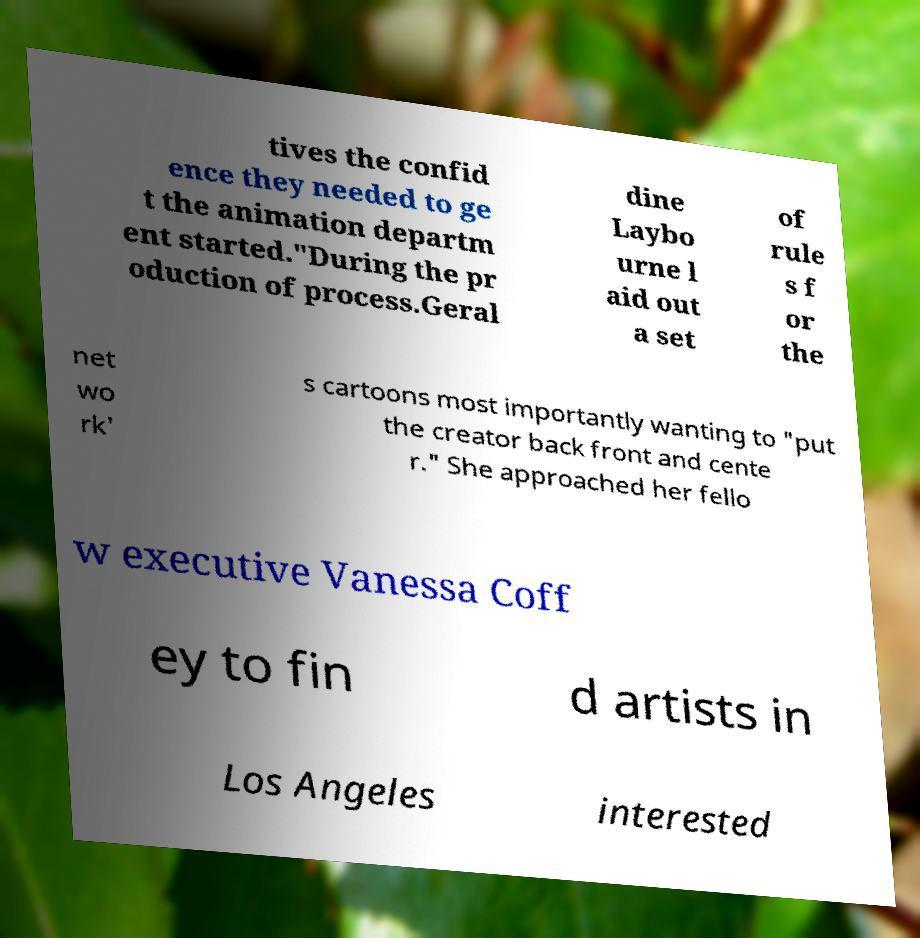There's text embedded in this image that I need extracted. Can you transcribe it verbatim? tives the confid ence they needed to ge t the animation departm ent started."During the pr oduction of process.Geral dine Laybo urne l aid out a set of rule s f or the net wo rk' s cartoons most importantly wanting to "put the creator back front and cente r." She approached her fello w executive Vanessa Coff ey to fin d artists in Los Angeles interested 